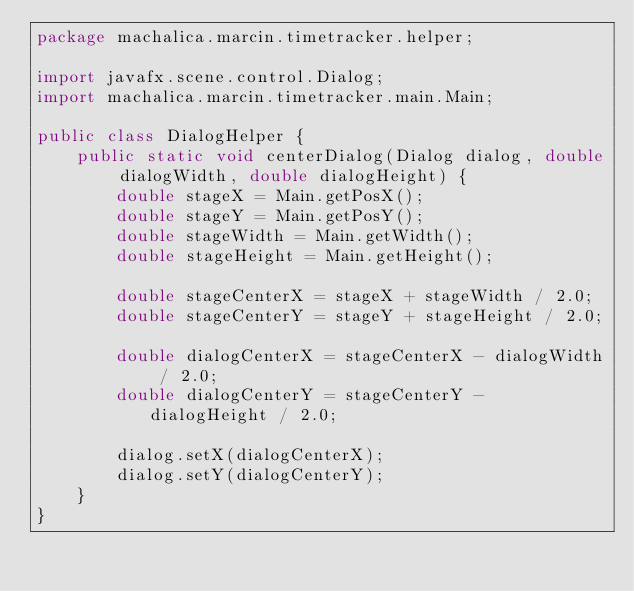Convert code to text. <code><loc_0><loc_0><loc_500><loc_500><_Java_>package machalica.marcin.timetracker.helper;

import javafx.scene.control.Dialog;
import machalica.marcin.timetracker.main.Main;

public class DialogHelper {
    public static void centerDialog(Dialog dialog, double dialogWidth, double dialogHeight) {
        double stageX = Main.getPosX();
        double stageY = Main.getPosY();
        double stageWidth = Main.getWidth();
        double stageHeight = Main.getHeight();

        double stageCenterX = stageX + stageWidth / 2.0;
        double stageCenterY = stageY + stageHeight / 2.0;

        double dialogCenterX = stageCenterX - dialogWidth / 2.0;
        double dialogCenterY = stageCenterY - dialogHeight / 2.0;

        dialog.setX(dialogCenterX);
        dialog.setY(dialogCenterY);
    }
}</code> 